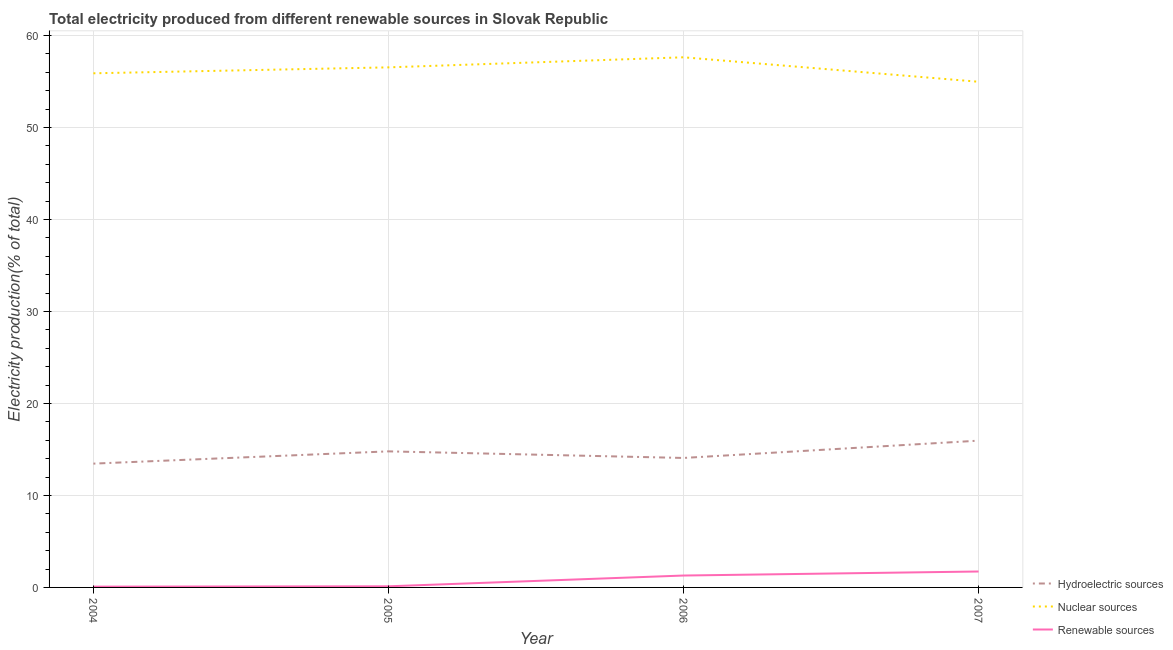How many different coloured lines are there?
Provide a succinct answer. 3. Does the line corresponding to percentage of electricity produced by renewable sources intersect with the line corresponding to percentage of electricity produced by nuclear sources?
Make the answer very short. No. Is the number of lines equal to the number of legend labels?
Your response must be concise. Yes. What is the percentage of electricity produced by renewable sources in 2007?
Give a very brief answer. 1.73. Across all years, what is the maximum percentage of electricity produced by renewable sources?
Make the answer very short. 1.73. Across all years, what is the minimum percentage of electricity produced by nuclear sources?
Provide a succinct answer. 54.98. In which year was the percentage of electricity produced by renewable sources maximum?
Offer a very short reply. 2007. In which year was the percentage of electricity produced by hydroelectric sources minimum?
Offer a terse response. 2004. What is the total percentage of electricity produced by nuclear sources in the graph?
Ensure brevity in your answer.  225.05. What is the difference between the percentage of electricity produced by renewable sources in 2006 and that in 2007?
Ensure brevity in your answer.  -0.44. What is the difference between the percentage of electricity produced by renewable sources in 2006 and the percentage of electricity produced by nuclear sources in 2005?
Make the answer very short. -55.25. What is the average percentage of electricity produced by hydroelectric sources per year?
Your answer should be compact. 14.57. In the year 2007, what is the difference between the percentage of electricity produced by renewable sources and percentage of electricity produced by nuclear sources?
Your response must be concise. -53.24. In how many years, is the percentage of electricity produced by renewable sources greater than 28 %?
Make the answer very short. 0. What is the ratio of the percentage of electricity produced by hydroelectric sources in 2006 to that in 2007?
Provide a short and direct response. 0.88. What is the difference between the highest and the second highest percentage of electricity produced by hydroelectric sources?
Keep it short and to the point. 1.16. What is the difference between the highest and the lowest percentage of electricity produced by nuclear sources?
Give a very brief answer. 2.66. Is it the case that in every year, the sum of the percentage of electricity produced by hydroelectric sources and percentage of electricity produced by nuclear sources is greater than the percentage of electricity produced by renewable sources?
Ensure brevity in your answer.  Yes. Does the percentage of electricity produced by hydroelectric sources monotonically increase over the years?
Offer a terse response. No. Is the percentage of electricity produced by nuclear sources strictly greater than the percentage of electricity produced by renewable sources over the years?
Ensure brevity in your answer.  Yes. Is the percentage of electricity produced by nuclear sources strictly less than the percentage of electricity produced by renewable sources over the years?
Make the answer very short. No. How many years are there in the graph?
Provide a succinct answer. 4. What is the difference between two consecutive major ticks on the Y-axis?
Offer a very short reply. 10. How many legend labels are there?
Give a very brief answer. 3. What is the title of the graph?
Give a very brief answer. Total electricity produced from different renewable sources in Slovak Republic. Does "Solid fuel" appear as one of the legend labels in the graph?
Provide a short and direct response. No. What is the Electricity production(% of total) in Hydroelectric sources in 2004?
Give a very brief answer. 13.46. What is the Electricity production(% of total) in Nuclear sources in 2004?
Your answer should be compact. 55.9. What is the Electricity production(% of total) in Renewable sources in 2004?
Provide a short and direct response. 0.09. What is the Electricity production(% of total) of Hydroelectric sources in 2005?
Your response must be concise. 14.79. What is the Electricity production(% of total) in Nuclear sources in 2005?
Your response must be concise. 56.54. What is the Electricity production(% of total) of Renewable sources in 2005?
Offer a terse response. 0.12. What is the Electricity production(% of total) in Hydroelectric sources in 2006?
Make the answer very short. 14.08. What is the Electricity production(% of total) of Nuclear sources in 2006?
Your response must be concise. 57.64. What is the Electricity production(% of total) in Renewable sources in 2006?
Your answer should be compact. 1.29. What is the Electricity production(% of total) in Hydroelectric sources in 2007?
Keep it short and to the point. 15.96. What is the Electricity production(% of total) of Nuclear sources in 2007?
Your answer should be compact. 54.98. What is the Electricity production(% of total) of Renewable sources in 2007?
Your response must be concise. 1.73. Across all years, what is the maximum Electricity production(% of total) of Hydroelectric sources?
Give a very brief answer. 15.96. Across all years, what is the maximum Electricity production(% of total) of Nuclear sources?
Your answer should be compact. 57.64. Across all years, what is the maximum Electricity production(% of total) in Renewable sources?
Your response must be concise. 1.73. Across all years, what is the minimum Electricity production(% of total) in Hydroelectric sources?
Your answer should be compact. 13.46. Across all years, what is the minimum Electricity production(% of total) in Nuclear sources?
Ensure brevity in your answer.  54.98. Across all years, what is the minimum Electricity production(% of total) of Renewable sources?
Keep it short and to the point. 0.09. What is the total Electricity production(% of total) in Hydroelectric sources in the graph?
Your answer should be compact. 58.29. What is the total Electricity production(% of total) of Nuclear sources in the graph?
Your response must be concise. 225.05. What is the total Electricity production(% of total) in Renewable sources in the graph?
Offer a terse response. 3.23. What is the difference between the Electricity production(% of total) in Hydroelectric sources in 2004 and that in 2005?
Make the answer very short. -1.33. What is the difference between the Electricity production(% of total) of Nuclear sources in 2004 and that in 2005?
Give a very brief answer. -0.65. What is the difference between the Electricity production(% of total) of Renewable sources in 2004 and that in 2005?
Your response must be concise. -0.04. What is the difference between the Electricity production(% of total) of Hydroelectric sources in 2004 and that in 2006?
Provide a short and direct response. -0.62. What is the difference between the Electricity production(% of total) in Nuclear sources in 2004 and that in 2006?
Your answer should be compact. -1.74. What is the difference between the Electricity production(% of total) in Renewable sources in 2004 and that in 2006?
Your answer should be very brief. -1.21. What is the difference between the Electricity production(% of total) of Hydroelectric sources in 2004 and that in 2007?
Ensure brevity in your answer.  -2.5. What is the difference between the Electricity production(% of total) in Nuclear sources in 2004 and that in 2007?
Give a very brief answer. 0.92. What is the difference between the Electricity production(% of total) of Renewable sources in 2004 and that in 2007?
Your response must be concise. -1.65. What is the difference between the Electricity production(% of total) of Hydroelectric sources in 2005 and that in 2006?
Your answer should be very brief. 0.72. What is the difference between the Electricity production(% of total) in Nuclear sources in 2005 and that in 2006?
Make the answer very short. -1.09. What is the difference between the Electricity production(% of total) of Renewable sources in 2005 and that in 2006?
Give a very brief answer. -1.17. What is the difference between the Electricity production(% of total) of Hydroelectric sources in 2005 and that in 2007?
Your answer should be very brief. -1.16. What is the difference between the Electricity production(% of total) in Nuclear sources in 2005 and that in 2007?
Offer a very short reply. 1.57. What is the difference between the Electricity production(% of total) of Renewable sources in 2005 and that in 2007?
Keep it short and to the point. -1.61. What is the difference between the Electricity production(% of total) in Hydroelectric sources in 2006 and that in 2007?
Give a very brief answer. -1.88. What is the difference between the Electricity production(% of total) in Nuclear sources in 2006 and that in 2007?
Offer a terse response. 2.66. What is the difference between the Electricity production(% of total) in Renewable sources in 2006 and that in 2007?
Offer a very short reply. -0.44. What is the difference between the Electricity production(% of total) in Hydroelectric sources in 2004 and the Electricity production(% of total) in Nuclear sources in 2005?
Your answer should be very brief. -43.08. What is the difference between the Electricity production(% of total) of Hydroelectric sources in 2004 and the Electricity production(% of total) of Renewable sources in 2005?
Make the answer very short. 13.34. What is the difference between the Electricity production(% of total) of Nuclear sources in 2004 and the Electricity production(% of total) of Renewable sources in 2005?
Ensure brevity in your answer.  55.78. What is the difference between the Electricity production(% of total) in Hydroelectric sources in 2004 and the Electricity production(% of total) in Nuclear sources in 2006?
Provide a succinct answer. -44.18. What is the difference between the Electricity production(% of total) in Hydroelectric sources in 2004 and the Electricity production(% of total) in Renewable sources in 2006?
Your answer should be very brief. 12.17. What is the difference between the Electricity production(% of total) of Nuclear sources in 2004 and the Electricity production(% of total) of Renewable sources in 2006?
Your answer should be very brief. 54.6. What is the difference between the Electricity production(% of total) in Hydroelectric sources in 2004 and the Electricity production(% of total) in Nuclear sources in 2007?
Give a very brief answer. -41.52. What is the difference between the Electricity production(% of total) in Hydroelectric sources in 2004 and the Electricity production(% of total) in Renewable sources in 2007?
Make the answer very short. 11.73. What is the difference between the Electricity production(% of total) of Nuclear sources in 2004 and the Electricity production(% of total) of Renewable sources in 2007?
Ensure brevity in your answer.  54.16. What is the difference between the Electricity production(% of total) in Hydroelectric sources in 2005 and the Electricity production(% of total) in Nuclear sources in 2006?
Your answer should be compact. -42.84. What is the difference between the Electricity production(% of total) in Hydroelectric sources in 2005 and the Electricity production(% of total) in Renewable sources in 2006?
Provide a short and direct response. 13.5. What is the difference between the Electricity production(% of total) of Nuclear sources in 2005 and the Electricity production(% of total) of Renewable sources in 2006?
Ensure brevity in your answer.  55.25. What is the difference between the Electricity production(% of total) of Hydroelectric sources in 2005 and the Electricity production(% of total) of Nuclear sources in 2007?
Ensure brevity in your answer.  -40.18. What is the difference between the Electricity production(% of total) in Hydroelectric sources in 2005 and the Electricity production(% of total) in Renewable sources in 2007?
Give a very brief answer. 13.06. What is the difference between the Electricity production(% of total) in Nuclear sources in 2005 and the Electricity production(% of total) in Renewable sources in 2007?
Ensure brevity in your answer.  54.81. What is the difference between the Electricity production(% of total) in Hydroelectric sources in 2006 and the Electricity production(% of total) in Nuclear sources in 2007?
Give a very brief answer. -40.9. What is the difference between the Electricity production(% of total) of Hydroelectric sources in 2006 and the Electricity production(% of total) of Renewable sources in 2007?
Provide a succinct answer. 12.34. What is the difference between the Electricity production(% of total) of Nuclear sources in 2006 and the Electricity production(% of total) of Renewable sources in 2007?
Make the answer very short. 55.9. What is the average Electricity production(% of total) of Hydroelectric sources per year?
Give a very brief answer. 14.57. What is the average Electricity production(% of total) of Nuclear sources per year?
Make the answer very short. 56.26. What is the average Electricity production(% of total) in Renewable sources per year?
Your answer should be very brief. 0.81. In the year 2004, what is the difference between the Electricity production(% of total) in Hydroelectric sources and Electricity production(% of total) in Nuclear sources?
Make the answer very short. -42.44. In the year 2004, what is the difference between the Electricity production(% of total) of Hydroelectric sources and Electricity production(% of total) of Renewable sources?
Provide a succinct answer. 13.37. In the year 2004, what is the difference between the Electricity production(% of total) in Nuclear sources and Electricity production(% of total) in Renewable sources?
Your response must be concise. 55.81. In the year 2005, what is the difference between the Electricity production(% of total) of Hydroelectric sources and Electricity production(% of total) of Nuclear sources?
Ensure brevity in your answer.  -41.75. In the year 2005, what is the difference between the Electricity production(% of total) of Hydroelectric sources and Electricity production(% of total) of Renewable sources?
Your response must be concise. 14.67. In the year 2005, what is the difference between the Electricity production(% of total) in Nuclear sources and Electricity production(% of total) in Renewable sources?
Provide a succinct answer. 56.42. In the year 2006, what is the difference between the Electricity production(% of total) in Hydroelectric sources and Electricity production(% of total) in Nuclear sources?
Your answer should be compact. -43.56. In the year 2006, what is the difference between the Electricity production(% of total) of Hydroelectric sources and Electricity production(% of total) of Renewable sources?
Your answer should be very brief. 12.78. In the year 2006, what is the difference between the Electricity production(% of total) of Nuclear sources and Electricity production(% of total) of Renewable sources?
Your response must be concise. 56.34. In the year 2007, what is the difference between the Electricity production(% of total) of Hydroelectric sources and Electricity production(% of total) of Nuclear sources?
Your response must be concise. -39.02. In the year 2007, what is the difference between the Electricity production(% of total) of Hydroelectric sources and Electricity production(% of total) of Renewable sources?
Your response must be concise. 14.23. In the year 2007, what is the difference between the Electricity production(% of total) of Nuclear sources and Electricity production(% of total) of Renewable sources?
Your answer should be very brief. 53.24. What is the ratio of the Electricity production(% of total) in Hydroelectric sources in 2004 to that in 2005?
Ensure brevity in your answer.  0.91. What is the ratio of the Electricity production(% of total) of Renewable sources in 2004 to that in 2005?
Give a very brief answer. 0.7. What is the ratio of the Electricity production(% of total) of Hydroelectric sources in 2004 to that in 2006?
Provide a succinct answer. 0.96. What is the ratio of the Electricity production(% of total) in Nuclear sources in 2004 to that in 2006?
Keep it short and to the point. 0.97. What is the ratio of the Electricity production(% of total) of Renewable sources in 2004 to that in 2006?
Your answer should be compact. 0.07. What is the ratio of the Electricity production(% of total) in Hydroelectric sources in 2004 to that in 2007?
Give a very brief answer. 0.84. What is the ratio of the Electricity production(% of total) in Nuclear sources in 2004 to that in 2007?
Provide a succinct answer. 1.02. What is the ratio of the Electricity production(% of total) in Renewable sources in 2004 to that in 2007?
Ensure brevity in your answer.  0.05. What is the ratio of the Electricity production(% of total) in Hydroelectric sources in 2005 to that in 2006?
Ensure brevity in your answer.  1.05. What is the ratio of the Electricity production(% of total) in Renewable sources in 2005 to that in 2006?
Offer a very short reply. 0.09. What is the ratio of the Electricity production(% of total) in Hydroelectric sources in 2005 to that in 2007?
Give a very brief answer. 0.93. What is the ratio of the Electricity production(% of total) in Nuclear sources in 2005 to that in 2007?
Your response must be concise. 1.03. What is the ratio of the Electricity production(% of total) of Renewable sources in 2005 to that in 2007?
Offer a very short reply. 0.07. What is the ratio of the Electricity production(% of total) of Hydroelectric sources in 2006 to that in 2007?
Offer a terse response. 0.88. What is the ratio of the Electricity production(% of total) in Nuclear sources in 2006 to that in 2007?
Keep it short and to the point. 1.05. What is the ratio of the Electricity production(% of total) in Renewable sources in 2006 to that in 2007?
Your answer should be very brief. 0.75. What is the difference between the highest and the second highest Electricity production(% of total) in Hydroelectric sources?
Offer a terse response. 1.16. What is the difference between the highest and the second highest Electricity production(% of total) in Nuclear sources?
Your answer should be compact. 1.09. What is the difference between the highest and the second highest Electricity production(% of total) of Renewable sources?
Make the answer very short. 0.44. What is the difference between the highest and the lowest Electricity production(% of total) in Hydroelectric sources?
Ensure brevity in your answer.  2.5. What is the difference between the highest and the lowest Electricity production(% of total) of Nuclear sources?
Keep it short and to the point. 2.66. What is the difference between the highest and the lowest Electricity production(% of total) of Renewable sources?
Offer a very short reply. 1.65. 